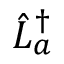Convert formula to latex. <formula><loc_0><loc_0><loc_500><loc_500>\hat { L } _ { a } ^ { \dag }</formula> 